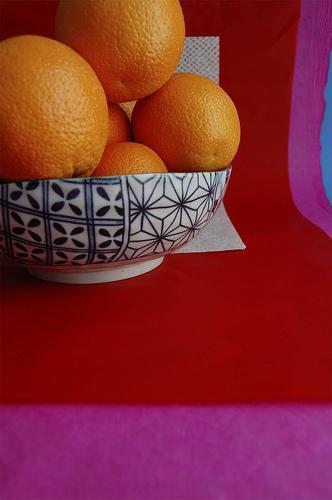What color is this fruit?
Quick response, please. Orange. What is the fruit in the bowl?
Quick response, please. Oranges. Is the sun shining on these oranges?
Keep it brief. No. How many oranges are in the bowl?
Keep it brief. 5. 